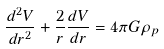Convert formula to latex. <formula><loc_0><loc_0><loc_500><loc_500>\frac { d ^ { 2 } V } { d r ^ { 2 } } + \frac { 2 } { r } \frac { d V } { d r } = 4 \pi G \rho _ { p }</formula> 